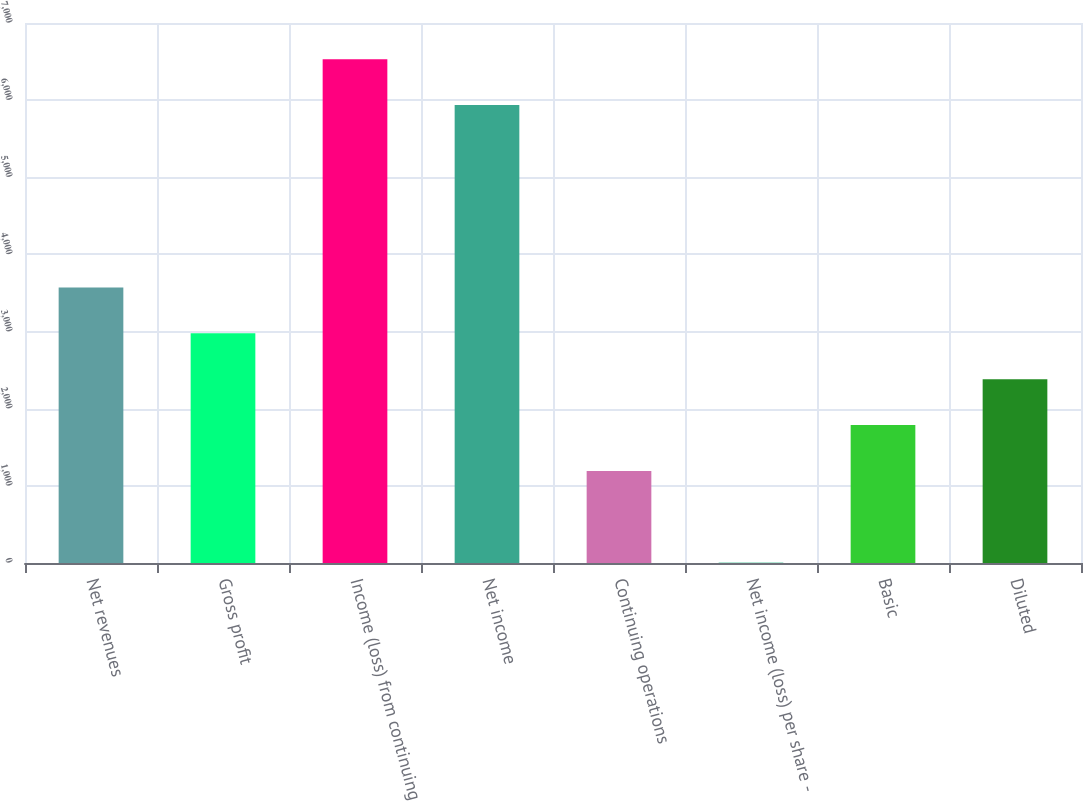Convert chart to OTSL. <chart><loc_0><loc_0><loc_500><loc_500><bar_chart><fcel>Net revenues<fcel>Gross profit<fcel>Income (loss) from continuing<fcel>Net income<fcel>Continuing operations<fcel>Net income (loss) per share -<fcel>Basic<fcel>Diluted<nl><fcel>3570.92<fcel>2976.65<fcel>6530.27<fcel>5936<fcel>1193.84<fcel>5.3<fcel>1788.11<fcel>2382.38<nl></chart> 